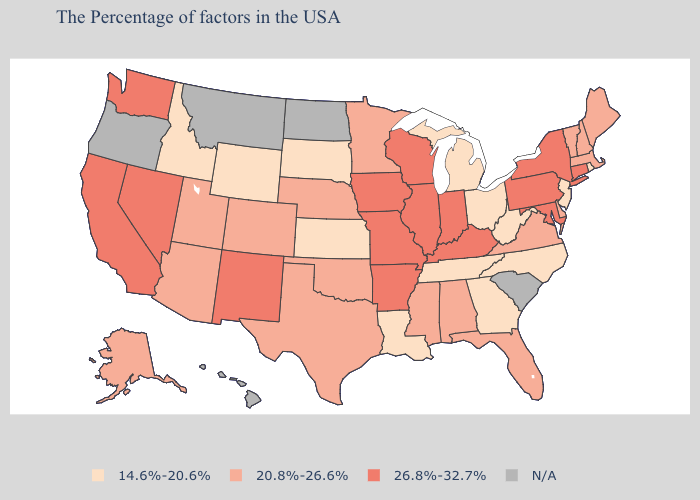What is the lowest value in states that border Montana?
Give a very brief answer. 14.6%-20.6%. Name the states that have a value in the range 26.8%-32.7%?
Concise answer only. Connecticut, New York, Maryland, Pennsylvania, Kentucky, Indiana, Wisconsin, Illinois, Missouri, Arkansas, Iowa, New Mexico, Nevada, California, Washington. Among the states that border New York , which have the lowest value?
Give a very brief answer. New Jersey. Which states hav the highest value in the West?
Answer briefly. New Mexico, Nevada, California, Washington. What is the lowest value in the USA?
Write a very short answer. 14.6%-20.6%. What is the value of Wyoming?
Concise answer only. 14.6%-20.6%. What is the value of Delaware?
Give a very brief answer. 20.8%-26.6%. What is the highest value in the MidWest ?
Keep it brief. 26.8%-32.7%. Name the states that have a value in the range 26.8%-32.7%?
Concise answer only. Connecticut, New York, Maryland, Pennsylvania, Kentucky, Indiana, Wisconsin, Illinois, Missouri, Arkansas, Iowa, New Mexico, Nevada, California, Washington. What is the lowest value in states that border Wisconsin?
Write a very short answer. 14.6%-20.6%. Name the states that have a value in the range 14.6%-20.6%?
Give a very brief answer. Rhode Island, New Jersey, North Carolina, West Virginia, Ohio, Georgia, Michigan, Tennessee, Louisiana, Kansas, South Dakota, Wyoming, Idaho. Is the legend a continuous bar?
Quick response, please. No. Name the states that have a value in the range 14.6%-20.6%?
Write a very short answer. Rhode Island, New Jersey, North Carolina, West Virginia, Ohio, Georgia, Michigan, Tennessee, Louisiana, Kansas, South Dakota, Wyoming, Idaho. 